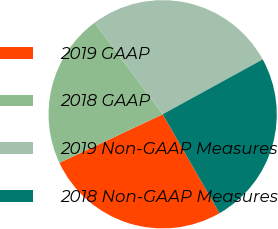Convert chart. <chart><loc_0><loc_0><loc_500><loc_500><pie_chart><fcel>2019 GAAP<fcel>2018 GAAP<fcel>2019 Non-GAAP Measures<fcel>2018 Non-GAAP Measures<nl><fcel>26.3%<fcel>21.83%<fcel>27.19%<fcel>24.68%<nl></chart> 